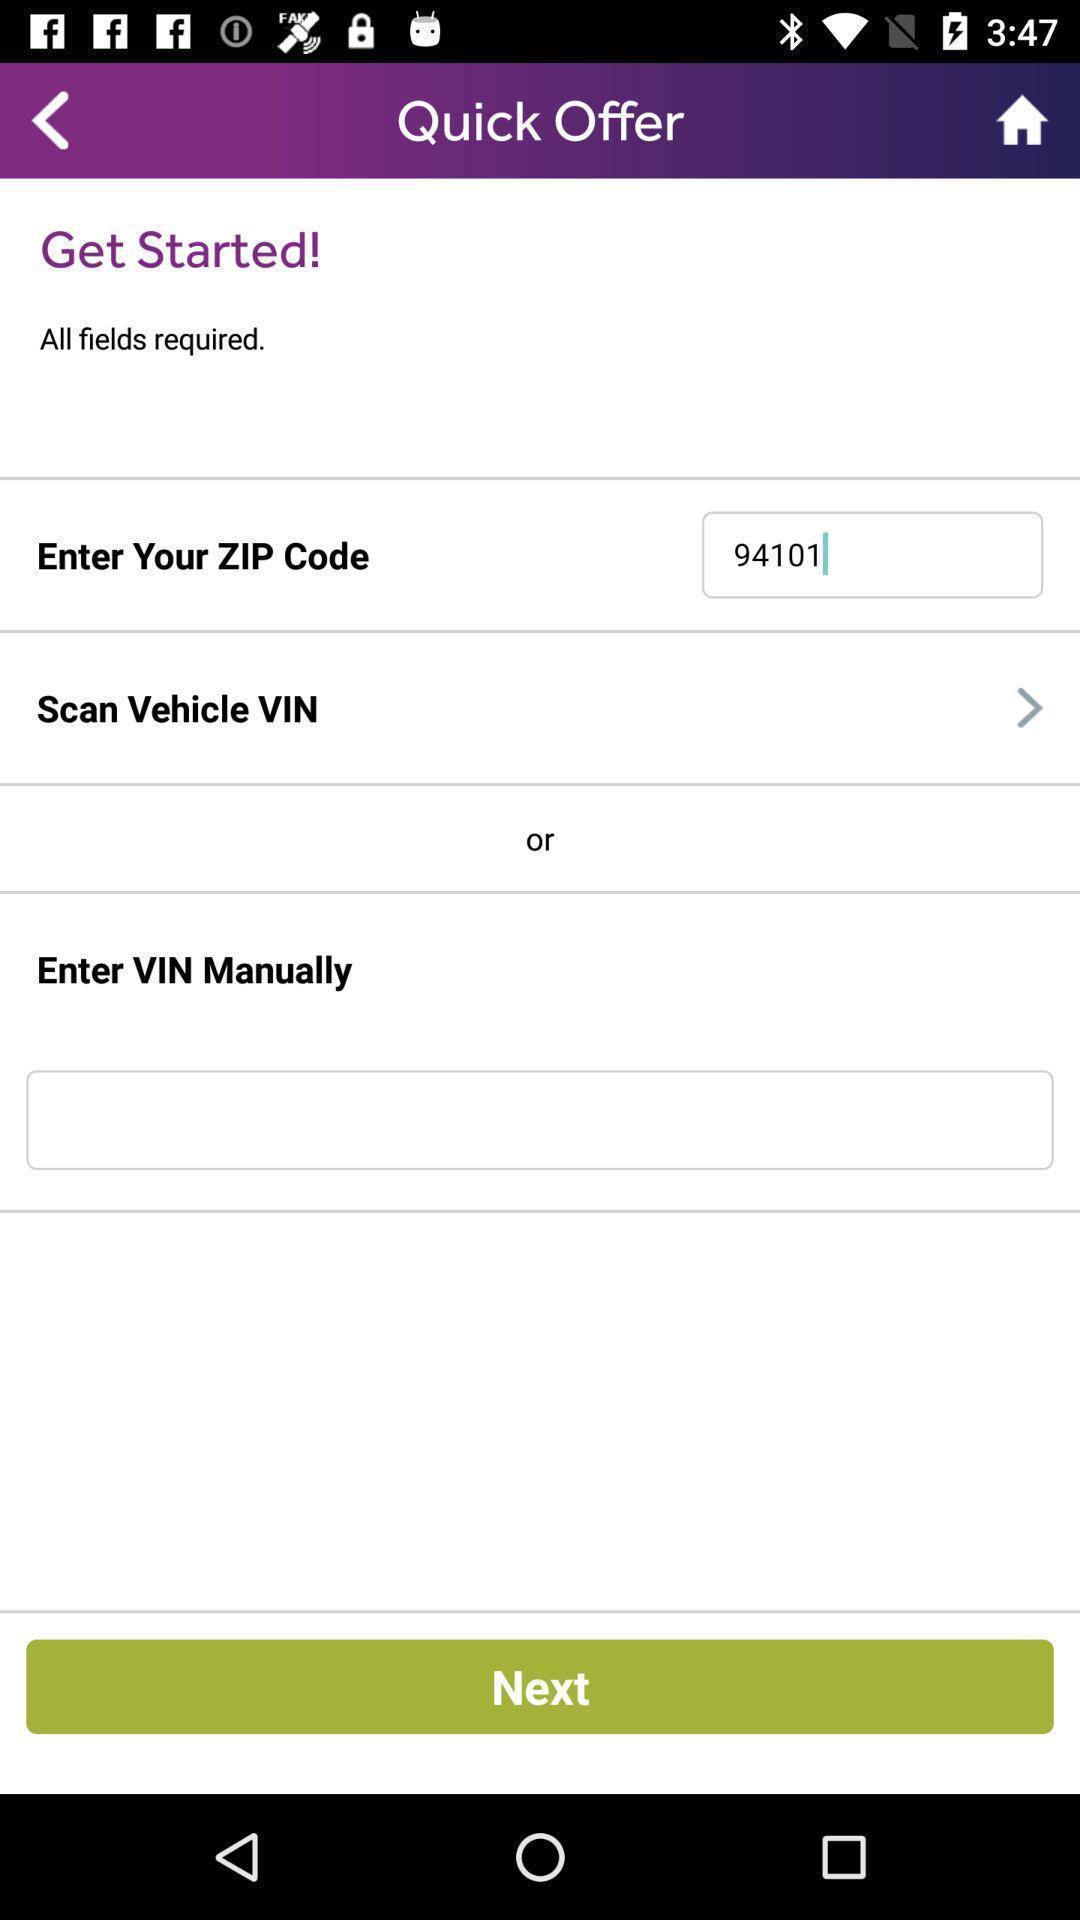Provide a textual representation of this image. Welcome page to enter details. 